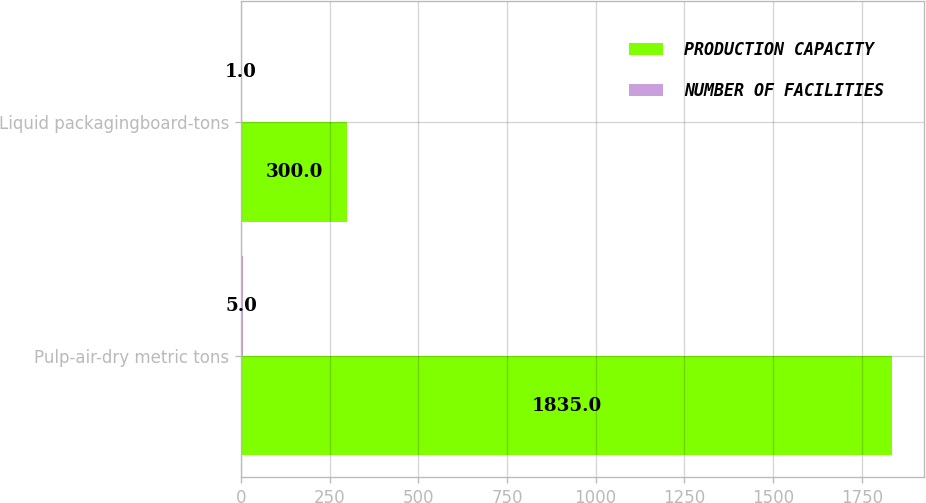Convert chart to OTSL. <chart><loc_0><loc_0><loc_500><loc_500><stacked_bar_chart><ecel><fcel>Pulp-air-dry metric tons<fcel>Liquid packagingboard-tons<nl><fcel>PRODUCTION CAPACITY<fcel>1835<fcel>300<nl><fcel>NUMBER OF FACILITIES<fcel>5<fcel>1<nl></chart> 